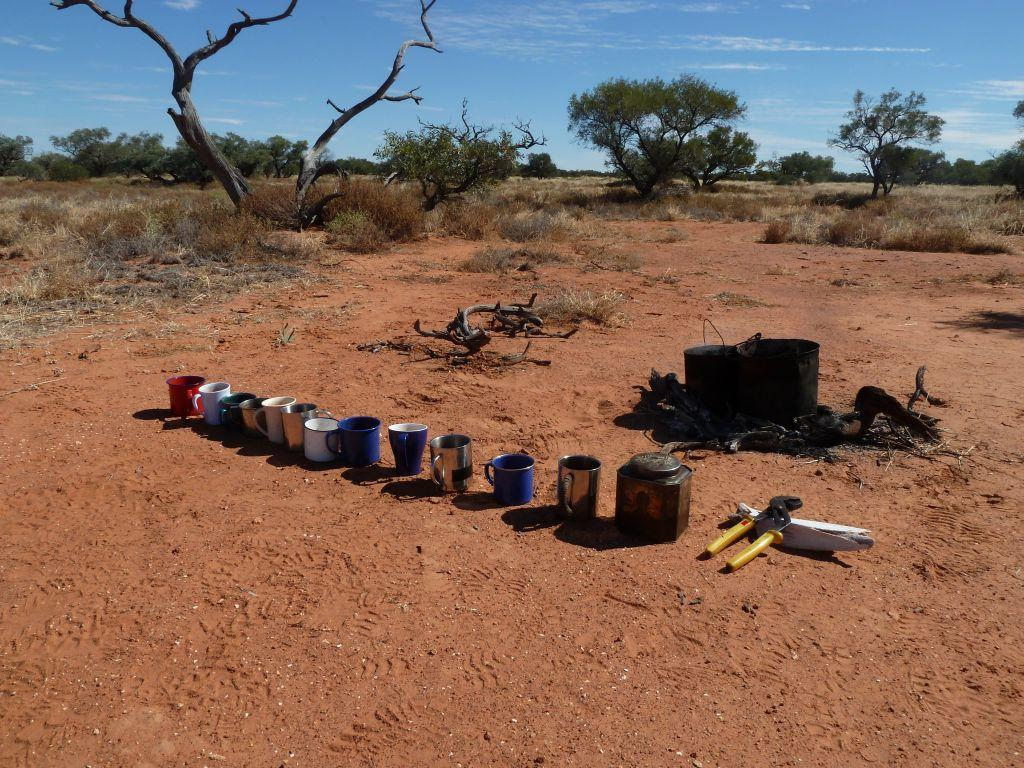What type of containers are visible in the image? There are coffee cups and jars in the image. What tool can be seen in the image? There is a plier in the image. What can be seen in the background of the image? There are trees, plants, and the sky visible in the background of the image. What type of root can be seen growing in the image? There is no root visible in the image; the focus is on coffee cups, jars, and a plier. 